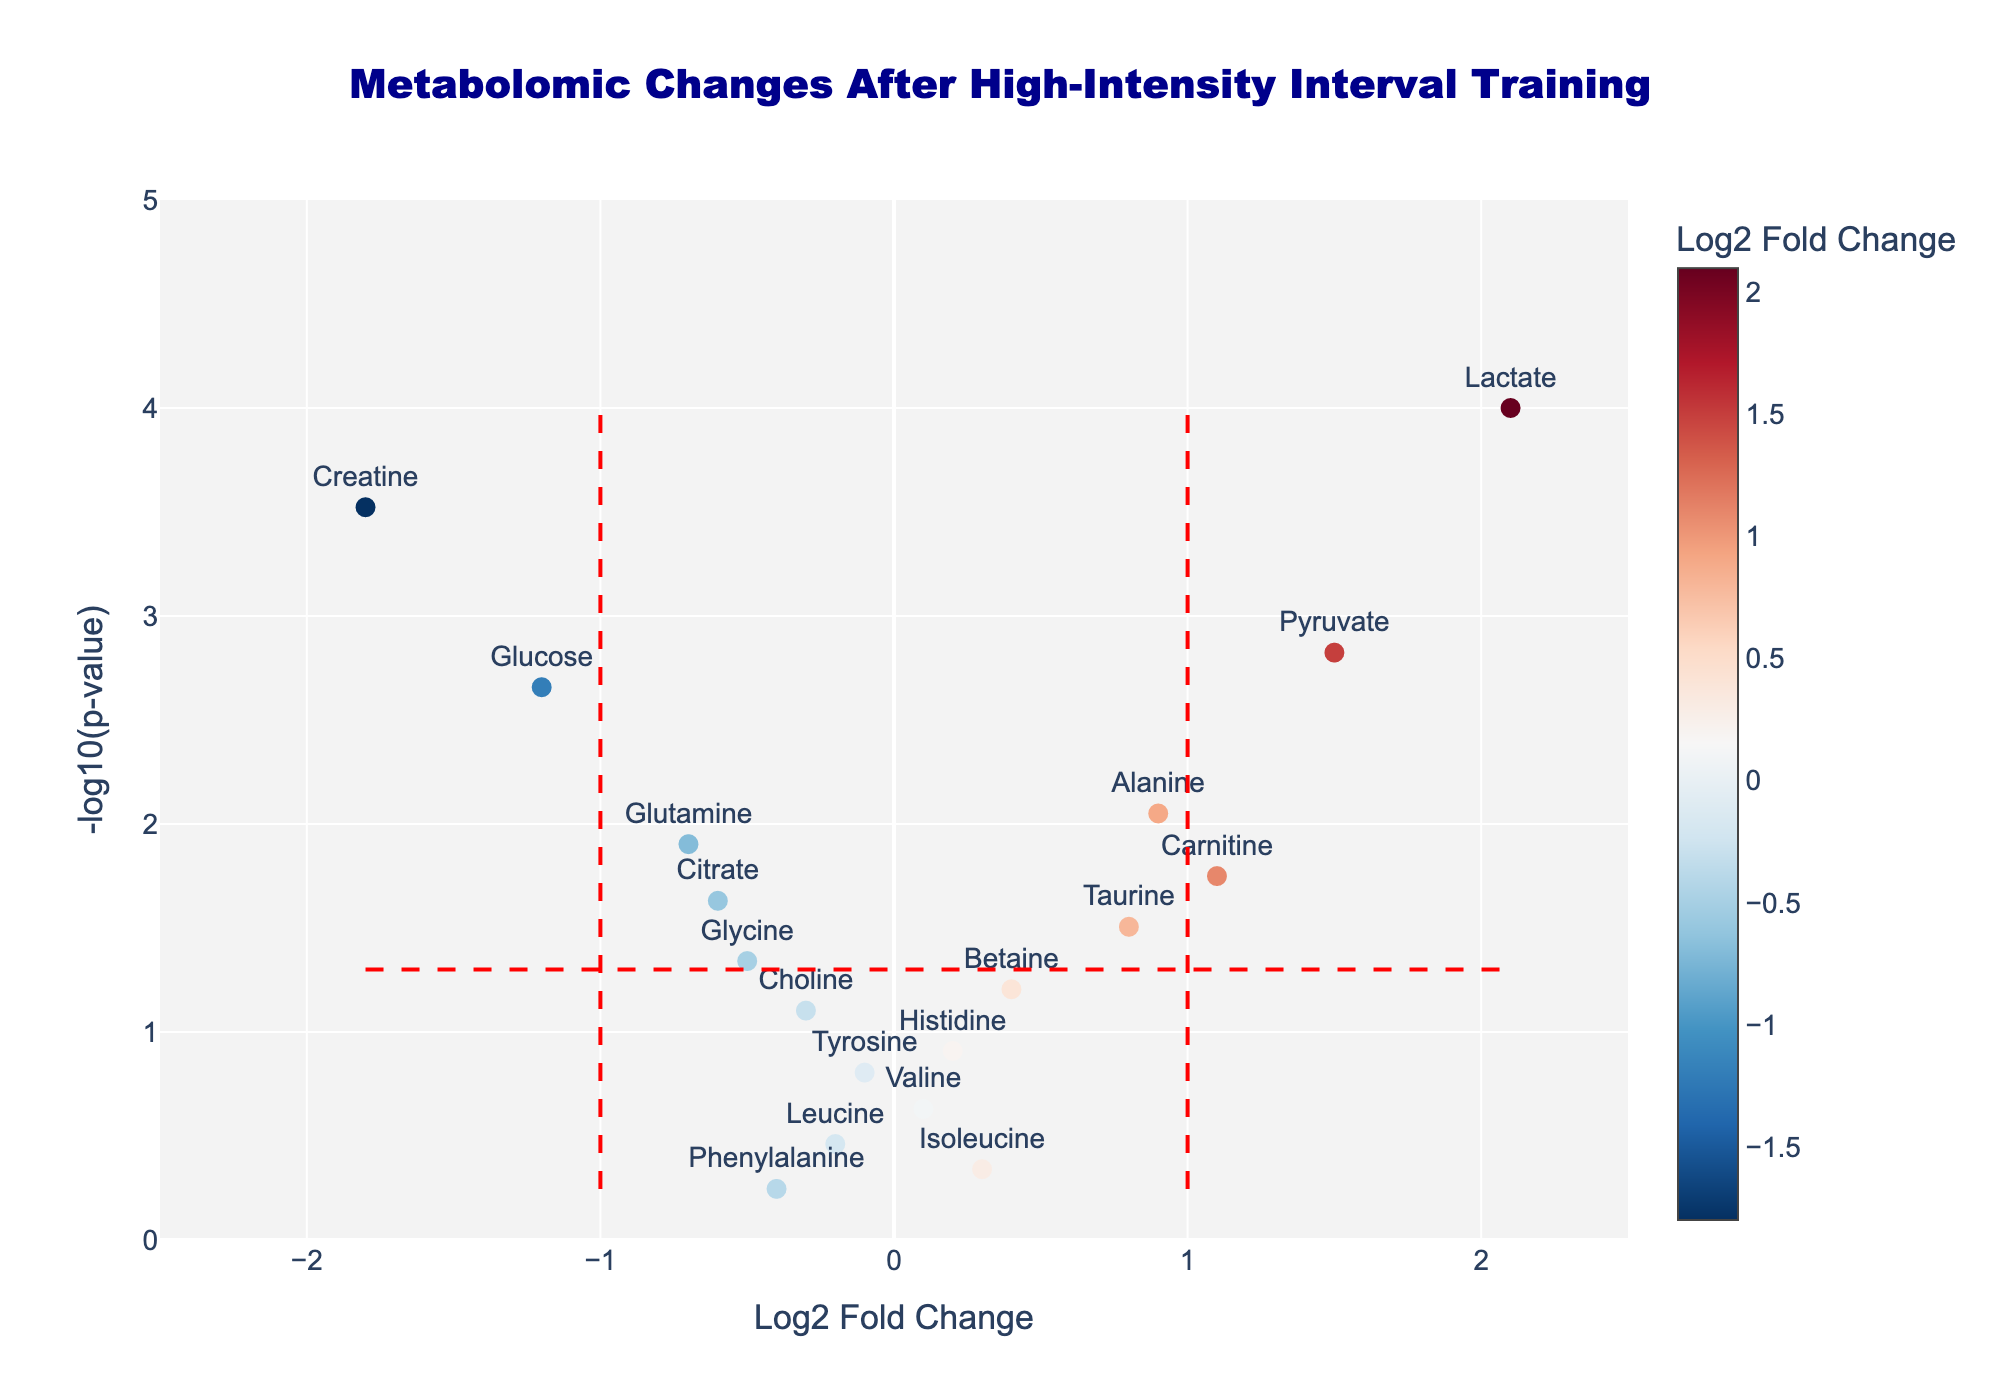What's the title of the figure? The title of the figure is usually found at the top and provides a brief summary of what the plot represents.
Answer: Metabolomic Changes After High-Intensity Interval Training How many metabolites have a Log2 Fold Change greater than 1? Look at the x-axis and count the number of data points with a Log2 Fold Change value greater than 1.
Answer: 3 Which metabolite shows the highest increase in Log2 Fold Change? Identify the data point with the highest value on the x-axis in the positive direction and refer to the label of that point.
Answer: Lactate Which metabolite has the smallest p-value? Find the data point with the highest value on the y-axis, as a smaller p-value corresponds to a higher -log10(p-value).
Answer: Lactate How many metabolites have a p-value below 0.05? Look at the number of data points above the red horizontal line that represents the -log10(0.05) threshold.
Answer: 10 Which metabolite shows the largest decrease in Log2 Fold Change? Identify the data point with the lowest value on the x-axis in the negative direction and refer to the label of that point.
Answer: Creatine What is the Log2 Fold Change and p-value of Carnitine? Find the data point labeled 'Carnitine', note the Log2 Fold Change on the x-axis and the p-value which can be derived from the y-axis (-log10(p-value)).
Answer: 1.1, 0.0178 Which of the metabolites have both a Log2 Fold Change less than -1 and a p-value below 0.05? Look for data points that are to the left of -1 on the x-axis and above the red horizontal line marking -log10(0.05) on the y-axis.
Answer: Creatine and Glucose What is the p-value threshold line set at in the figure? The red horizontal line indicates the p-value threshold, which is shown on the y-axis as -log10(0.05).
Answer: 0.05 How many metabolites have a Log2 Fold Change within the range -1 to 1 and a p-value above 0.05? Count the number of data points within the specified Log2 Fold Change range and below the red horizontal line marking the p-value threshold.
Answer: 8 Which metabolites are considered statistically significant with a Log2 Fold Change between -1 and 1? Look for data points within the x-axis range of -1 to 1 that are above the red horizontal line indicating statistical significance.
Answer: Alanine, Glutamine, Carnitine, Citrate, Taurine 